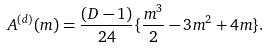Convert formula to latex. <formula><loc_0><loc_0><loc_500><loc_500>A ^ { ( d ) } ( m ) = \frac { ( D - 1 ) } { 2 4 } \{ \frac { m ^ { 3 } } { 2 } - 3 m ^ { 2 } + 4 m \} .</formula> 